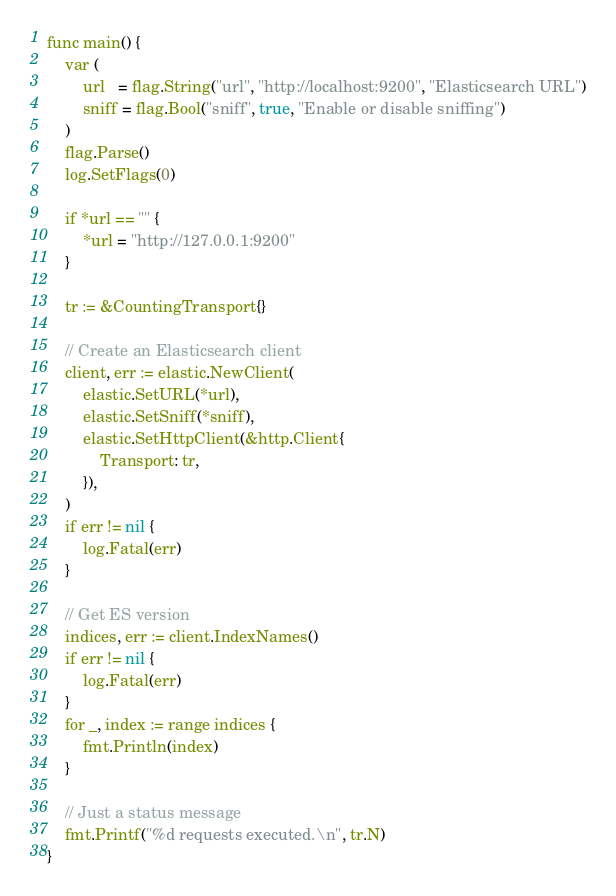Convert code to text. <code><loc_0><loc_0><loc_500><loc_500><_Go_>func main() {
	var (
		url   = flag.String("url", "http://localhost:9200", "Elasticsearch URL")
		sniff = flag.Bool("sniff", true, "Enable or disable sniffing")
	)
	flag.Parse()
	log.SetFlags(0)

	if *url == "" {
		*url = "http://127.0.0.1:9200"
	}

	tr := &CountingTransport{}

	// Create an Elasticsearch client
	client, err := elastic.NewClient(
		elastic.SetURL(*url),
		elastic.SetSniff(*sniff),
		elastic.SetHttpClient(&http.Client{
			Transport: tr,
		}),
	)
	if err != nil {
		log.Fatal(err)
	}

	// Get ES version
	indices, err := client.IndexNames()
	if err != nil {
		log.Fatal(err)
	}
	for _, index := range indices {
		fmt.Println(index)
	}

	// Just a status message
	fmt.Printf("%d requests executed.\n", tr.N)
}
</code> 